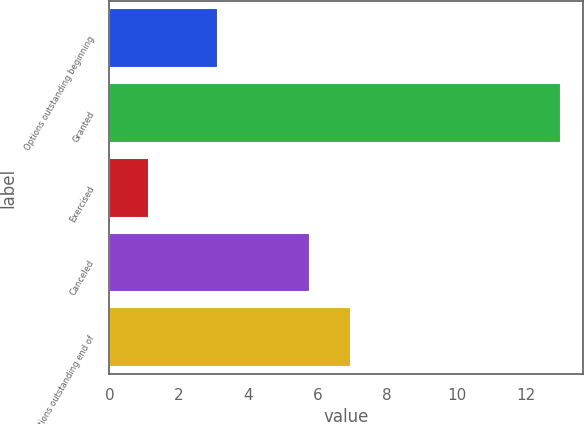<chart> <loc_0><loc_0><loc_500><loc_500><bar_chart><fcel>Options outstanding beginning<fcel>Granted<fcel>Exercised<fcel>Canceled<fcel>Options outstanding end of<nl><fcel>3.13<fcel>13<fcel>1.13<fcel>5.77<fcel>6.96<nl></chart> 